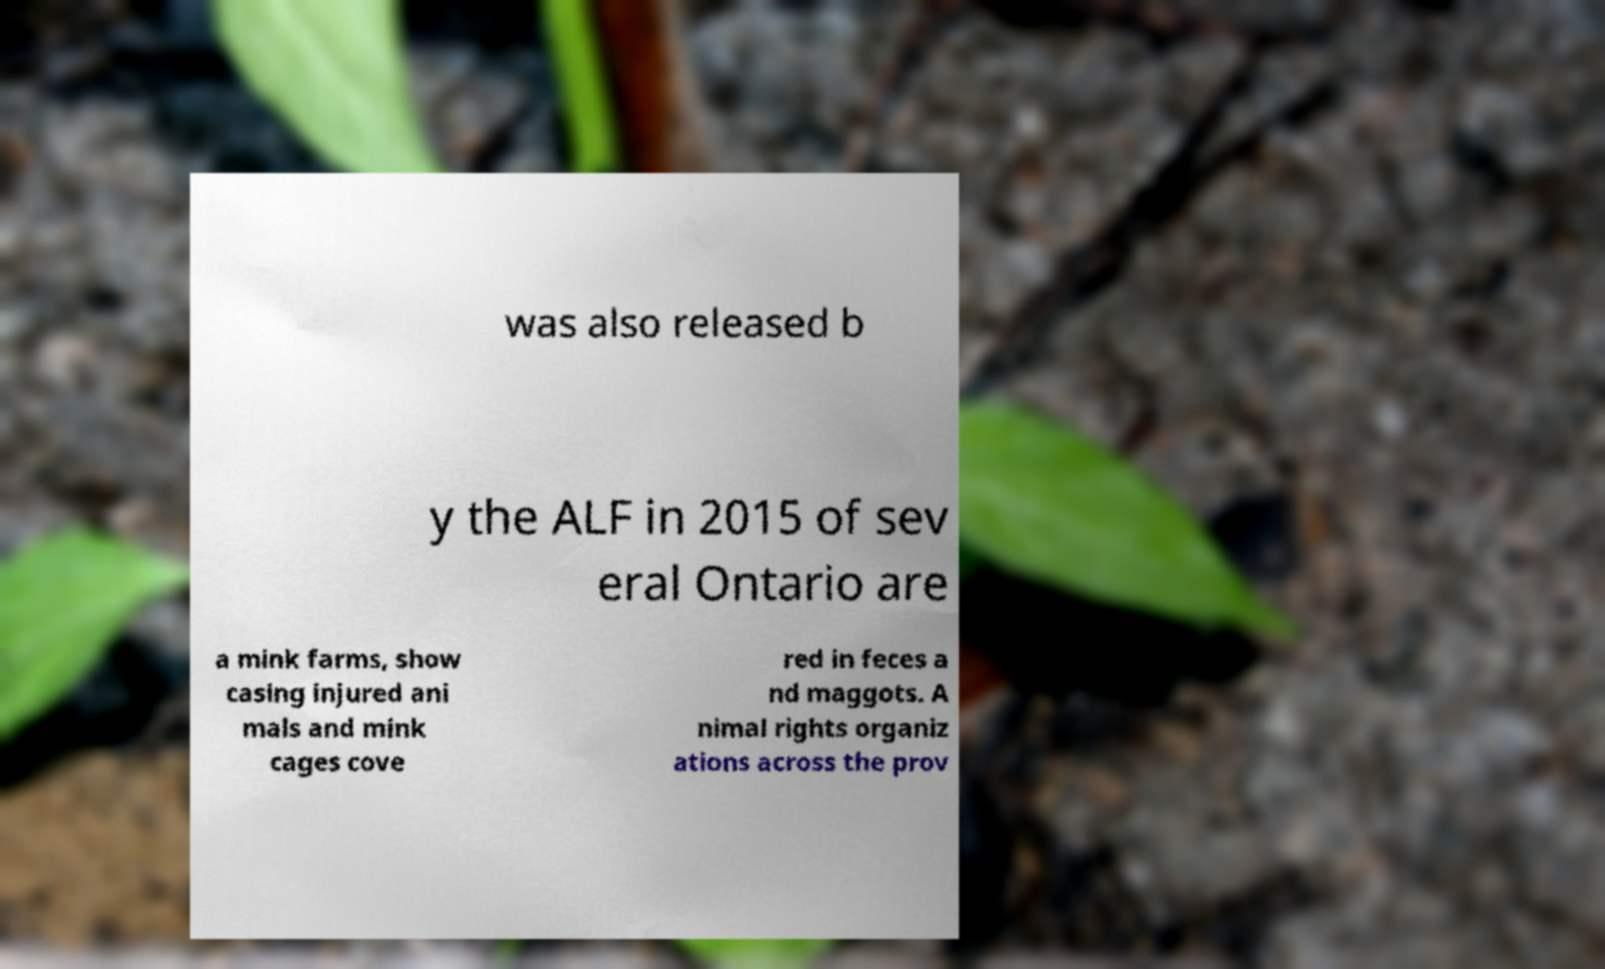Please identify and transcribe the text found in this image. was also released b y the ALF in 2015 of sev eral Ontario are a mink farms, show casing injured ani mals and mink cages cove red in feces a nd maggots. A nimal rights organiz ations across the prov 